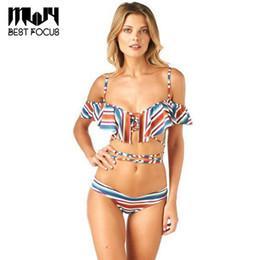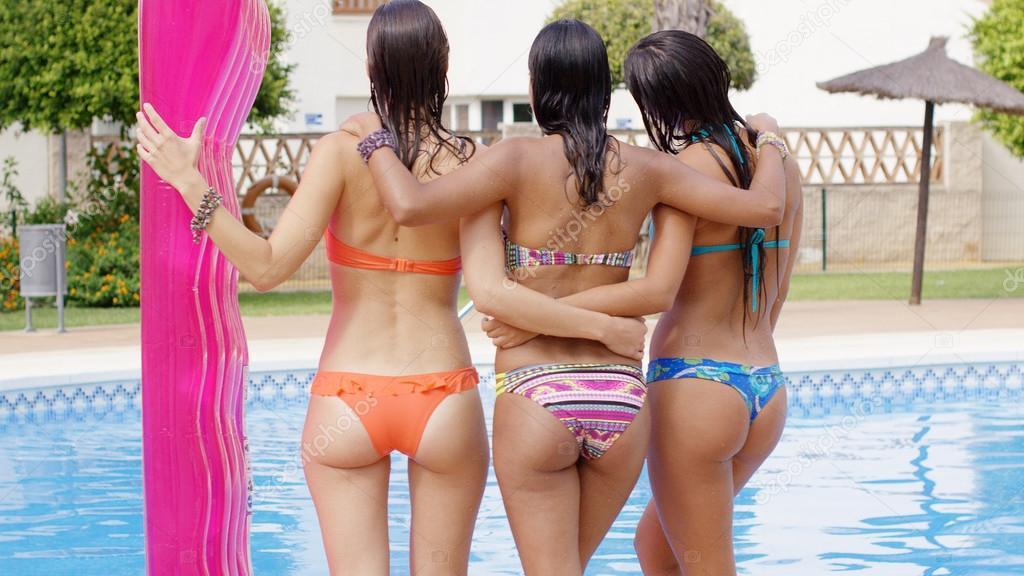The first image is the image on the left, the second image is the image on the right. Evaluate the accuracy of this statement regarding the images: "One image shows a trio of bikini models with backs to the camera and arms around each other.". Is it true? Answer yes or no. Yes. The first image is the image on the left, the second image is the image on the right. Considering the images on both sides, is "One woman poses in a bikini in one image, while three women pose in the other image." valid? Answer yes or no. Yes. 